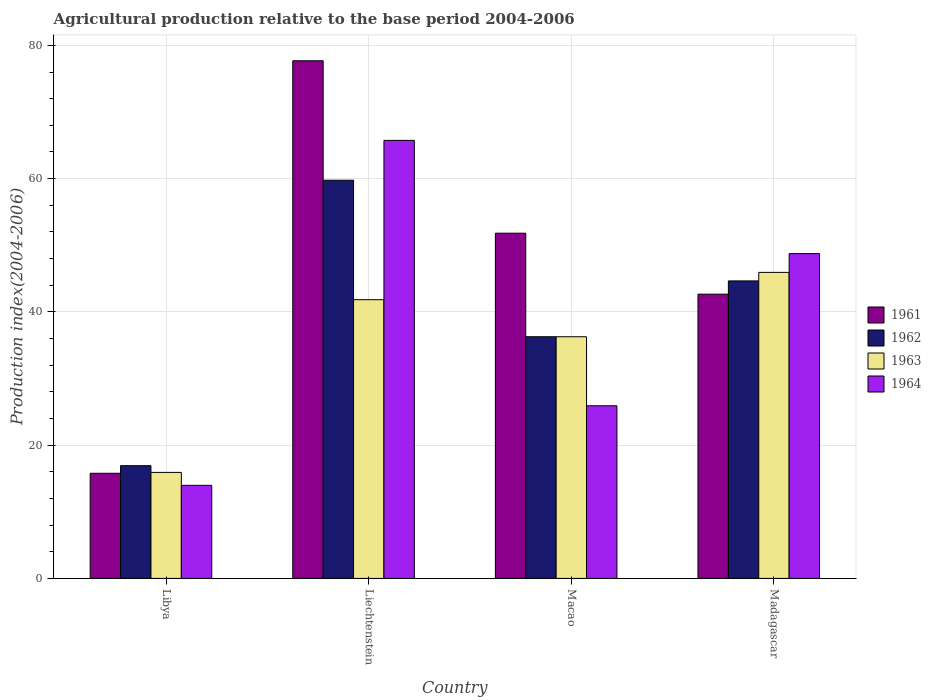How many different coloured bars are there?
Keep it short and to the point. 4. How many groups of bars are there?
Your answer should be very brief. 4. What is the label of the 3rd group of bars from the left?
Your answer should be very brief. Macao. In how many cases, is the number of bars for a given country not equal to the number of legend labels?
Ensure brevity in your answer.  0. What is the agricultural production index in 1962 in Macao?
Give a very brief answer. 36.27. Across all countries, what is the maximum agricultural production index in 1964?
Ensure brevity in your answer.  65.74. Across all countries, what is the minimum agricultural production index in 1961?
Keep it short and to the point. 15.78. In which country was the agricultural production index in 1964 maximum?
Offer a very short reply. Liechtenstein. In which country was the agricultural production index in 1961 minimum?
Provide a succinct answer. Libya. What is the total agricultural production index in 1964 in the graph?
Keep it short and to the point. 154.37. What is the difference between the agricultural production index in 1961 in Libya and that in Madagascar?
Offer a terse response. -26.88. What is the difference between the agricultural production index in 1963 in Liechtenstein and the agricultural production index in 1961 in Madagascar?
Ensure brevity in your answer.  -0.83. What is the average agricultural production index in 1961 per country?
Your answer should be very brief. 46.98. What is the difference between the agricultural production index of/in 1964 and agricultural production index of/in 1961 in Libya?
Make the answer very short. -1.81. In how many countries, is the agricultural production index in 1961 greater than 44?
Your answer should be compact. 2. What is the ratio of the agricultural production index in 1961 in Liechtenstein to that in Macao?
Your response must be concise. 1.5. What is the difference between the highest and the second highest agricultural production index in 1964?
Provide a short and direct response. -16.99. What is the difference between the highest and the lowest agricultural production index in 1963?
Provide a short and direct response. 30.02. What does the 3rd bar from the left in Madagascar represents?
Make the answer very short. 1963. How many countries are there in the graph?
Offer a very short reply. 4. What is the difference between two consecutive major ticks on the Y-axis?
Your answer should be compact. 20. Are the values on the major ticks of Y-axis written in scientific E-notation?
Give a very brief answer. No. Does the graph contain grids?
Your response must be concise. Yes. Where does the legend appear in the graph?
Offer a very short reply. Center right. How many legend labels are there?
Offer a very short reply. 4. How are the legend labels stacked?
Offer a terse response. Vertical. What is the title of the graph?
Offer a very short reply. Agricultural production relative to the base period 2004-2006. Does "2010" appear as one of the legend labels in the graph?
Make the answer very short. No. What is the label or title of the Y-axis?
Keep it short and to the point. Production index(2004-2006). What is the Production index(2004-2006) in 1961 in Libya?
Offer a terse response. 15.78. What is the Production index(2004-2006) in 1962 in Libya?
Keep it short and to the point. 16.92. What is the Production index(2004-2006) of 1963 in Libya?
Give a very brief answer. 15.91. What is the Production index(2004-2006) of 1964 in Libya?
Your answer should be very brief. 13.97. What is the Production index(2004-2006) in 1961 in Liechtenstein?
Provide a short and direct response. 77.69. What is the Production index(2004-2006) of 1962 in Liechtenstein?
Make the answer very short. 59.76. What is the Production index(2004-2006) in 1963 in Liechtenstein?
Provide a succinct answer. 41.83. What is the Production index(2004-2006) of 1964 in Liechtenstein?
Keep it short and to the point. 65.74. What is the Production index(2004-2006) of 1961 in Macao?
Ensure brevity in your answer.  51.81. What is the Production index(2004-2006) in 1962 in Macao?
Offer a very short reply. 36.27. What is the Production index(2004-2006) in 1963 in Macao?
Keep it short and to the point. 36.27. What is the Production index(2004-2006) in 1964 in Macao?
Your answer should be very brief. 25.91. What is the Production index(2004-2006) of 1961 in Madagascar?
Give a very brief answer. 42.66. What is the Production index(2004-2006) in 1962 in Madagascar?
Keep it short and to the point. 44.65. What is the Production index(2004-2006) of 1963 in Madagascar?
Provide a succinct answer. 45.93. What is the Production index(2004-2006) of 1964 in Madagascar?
Offer a very short reply. 48.75. Across all countries, what is the maximum Production index(2004-2006) in 1961?
Your response must be concise. 77.69. Across all countries, what is the maximum Production index(2004-2006) of 1962?
Your answer should be compact. 59.76. Across all countries, what is the maximum Production index(2004-2006) of 1963?
Ensure brevity in your answer.  45.93. Across all countries, what is the maximum Production index(2004-2006) in 1964?
Provide a succinct answer. 65.74. Across all countries, what is the minimum Production index(2004-2006) in 1961?
Make the answer very short. 15.78. Across all countries, what is the minimum Production index(2004-2006) of 1962?
Provide a succinct answer. 16.92. Across all countries, what is the minimum Production index(2004-2006) in 1963?
Your answer should be compact. 15.91. Across all countries, what is the minimum Production index(2004-2006) of 1964?
Offer a terse response. 13.97. What is the total Production index(2004-2006) of 1961 in the graph?
Ensure brevity in your answer.  187.94. What is the total Production index(2004-2006) of 1962 in the graph?
Your answer should be compact. 157.6. What is the total Production index(2004-2006) in 1963 in the graph?
Provide a short and direct response. 139.94. What is the total Production index(2004-2006) in 1964 in the graph?
Your response must be concise. 154.37. What is the difference between the Production index(2004-2006) of 1961 in Libya and that in Liechtenstein?
Your answer should be compact. -61.91. What is the difference between the Production index(2004-2006) of 1962 in Libya and that in Liechtenstein?
Ensure brevity in your answer.  -42.84. What is the difference between the Production index(2004-2006) of 1963 in Libya and that in Liechtenstein?
Ensure brevity in your answer.  -25.92. What is the difference between the Production index(2004-2006) of 1964 in Libya and that in Liechtenstein?
Offer a terse response. -51.77. What is the difference between the Production index(2004-2006) in 1961 in Libya and that in Macao?
Your answer should be compact. -36.03. What is the difference between the Production index(2004-2006) in 1962 in Libya and that in Macao?
Provide a short and direct response. -19.35. What is the difference between the Production index(2004-2006) of 1963 in Libya and that in Macao?
Ensure brevity in your answer.  -20.36. What is the difference between the Production index(2004-2006) in 1964 in Libya and that in Macao?
Offer a terse response. -11.94. What is the difference between the Production index(2004-2006) in 1961 in Libya and that in Madagascar?
Provide a succinct answer. -26.88. What is the difference between the Production index(2004-2006) in 1962 in Libya and that in Madagascar?
Offer a terse response. -27.73. What is the difference between the Production index(2004-2006) in 1963 in Libya and that in Madagascar?
Provide a short and direct response. -30.02. What is the difference between the Production index(2004-2006) in 1964 in Libya and that in Madagascar?
Make the answer very short. -34.78. What is the difference between the Production index(2004-2006) in 1961 in Liechtenstein and that in Macao?
Your response must be concise. 25.88. What is the difference between the Production index(2004-2006) in 1962 in Liechtenstein and that in Macao?
Your response must be concise. 23.49. What is the difference between the Production index(2004-2006) in 1963 in Liechtenstein and that in Macao?
Offer a very short reply. 5.56. What is the difference between the Production index(2004-2006) in 1964 in Liechtenstein and that in Macao?
Give a very brief answer. 39.83. What is the difference between the Production index(2004-2006) of 1961 in Liechtenstein and that in Madagascar?
Provide a short and direct response. 35.03. What is the difference between the Production index(2004-2006) of 1962 in Liechtenstein and that in Madagascar?
Your response must be concise. 15.11. What is the difference between the Production index(2004-2006) in 1963 in Liechtenstein and that in Madagascar?
Keep it short and to the point. -4.1. What is the difference between the Production index(2004-2006) of 1964 in Liechtenstein and that in Madagascar?
Your response must be concise. 16.99. What is the difference between the Production index(2004-2006) in 1961 in Macao and that in Madagascar?
Provide a short and direct response. 9.15. What is the difference between the Production index(2004-2006) in 1962 in Macao and that in Madagascar?
Ensure brevity in your answer.  -8.38. What is the difference between the Production index(2004-2006) of 1963 in Macao and that in Madagascar?
Provide a succinct answer. -9.66. What is the difference between the Production index(2004-2006) in 1964 in Macao and that in Madagascar?
Keep it short and to the point. -22.84. What is the difference between the Production index(2004-2006) in 1961 in Libya and the Production index(2004-2006) in 1962 in Liechtenstein?
Make the answer very short. -43.98. What is the difference between the Production index(2004-2006) in 1961 in Libya and the Production index(2004-2006) in 1963 in Liechtenstein?
Offer a very short reply. -26.05. What is the difference between the Production index(2004-2006) of 1961 in Libya and the Production index(2004-2006) of 1964 in Liechtenstein?
Your answer should be very brief. -49.96. What is the difference between the Production index(2004-2006) of 1962 in Libya and the Production index(2004-2006) of 1963 in Liechtenstein?
Give a very brief answer. -24.91. What is the difference between the Production index(2004-2006) of 1962 in Libya and the Production index(2004-2006) of 1964 in Liechtenstein?
Offer a terse response. -48.82. What is the difference between the Production index(2004-2006) of 1963 in Libya and the Production index(2004-2006) of 1964 in Liechtenstein?
Make the answer very short. -49.83. What is the difference between the Production index(2004-2006) in 1961 in Libya and the Production index(2004-2006) in 1962 in Macao?
Your answer should be very brief. -20.49. What is the difference between the Production index(2004-2006) of 1961 in Libya and the Production index(2004-2006) of 1963 in Macao?
Offer a very short reply. -20.49. What is the difference between the Production index(2004-2006) in 1961 in Libya and the Production index(2004-2006) in 1964 in Macao?
Keep it short and to the point. -10.13. What is the difference between the Production index(2004-2006) in 1962 in Libya and the Production index(2004-2006) in 1963 in Macao?
Your answer should be compact. -19.35. What is the difference between the Production index(2004-2006) in 1962 in Libya and the Production index(2004-2006) in 1964 in Macao?
Keep it short and to the point. -8.99. What is the difference between the Production index(2004-2006) of 1963 in Libya and the Production index(2004-2006) of 1964 in Macao?
Offer a very short reply. -10. What is the difference between the Production index(2004-2006) in 1961 in Libya and the Production index(2004-2006) in 1962 in Madagascar?
Make the answer very short. -28.87. What is the difference between the Production index(2004-2006) of 1961 in Libya and the Production index(2004-2006) of 1963 in Madagascar?
Keep it short and to the point. -30.15. What is the difference between the Production index(2004-2006) of 1961 in Libya and the Production index(2004-2006) of 1964 in Madagascar?
Give a very brief answer. -32.97. What is the difference between the Production index(2004-2006) of 1962 in Libya and the Production index(2004-2006) of 1963 in Madagascar?
Make the answer very short. -29.01. What is the difference between the Production index(2004-2006) of 1962 in Libya and the Production index(2004-2006) of 1964 in Madagascar?
Provide a short and direct response. -31.83. What is the difference between the Production index(2004-2006) of 1963 in Libya and the Production index(2004-2006) of 1964 in Madagascar?
Your response must be concise. -32.84. What is the difference between the Production index(2004-2006) in 1961 in Liechtenstein and the Production index(2004-2006) in 1962 in Macao?
Offer a terse response. 41.42. What is the difference between the Production index(2004-2006) of 1961 in Liechtenstein and the Production index(2004-2006) of 1963 in Macao?
Your response must be concise. 41.42. What is the difference between the Production index(2004-2006) in 1961 in Liechtenstein and the Production index(2004-2006) in 1964 in Macao?
Offer a very short reply. 51.78. What is the difference between the Production index(2004-2006) in 1962 in Liechtenstein and the Production index(2004-2006) in 1963 in Macao?
Ensure brevity in your answer.  23.49. What is the difference between the Production index(2004-2006) of 1962 in Liechtenstein and the Production index(2004-2006) of 1964 in Macao?
Make the answer very short. 33.85. What is the difference between the Production index(2004-2006) in 1963 in Liechtenstein and the Production index(2004-2006) in 1964 in Macao?
Your answer should be compact. 15.92. What is the difference between the Production index(2004-2006) in 1961 in Liechtenstein and the Production index(2004-2006) in 1962 in Madagascar?
Your response must be concise. 33.04. What is the difference between the Production index(2004-2006) in 1961 in Liechtenstein and the Production index(2004-2006) in 1963 in Madagascar?
Provide a short and direct response. 31.76. What is the difference between the Production index(2004-2006) in 1961 in Liechtenstein and the Production index(2004-2006) in 1964 in Madagascar?
Provide a succinct answer. 28.94. What is the difference between the Production index(2004-2006) in 1962 in Liechtenstein and the Production index(2004-2006) in 1963 in Madagascar?
Your answer should be compact. 13.83. What is the difference between the Production index(2004-2006) of 1962 in Liechtenstein and the Production index(2004-2006) of 1964 in Madagascar?
Keep it short and to the point. 11.01. What is the difference between the Production index(2004-2006) of 1963 in Liechtenstein and the Production index(2004-2006) of 1964 in Madagascar?
Keep it short and to the point. -6.92. What is the difference between the Production index(2004-2006) of 1961 in Macao and the Production index(2004-2006) of 1962 in Madagascar?
Keep it short and to the point. 7.16. What is the difference between the Production index(2004-2006) in 1961 in Macao and the Production index(2004-2006) in 1963 in Madagascar?
Ensure brevity in your answer.  5.88. What is the difference between the Production index(2004-2006) in 1961 in Macao and the Production index(2004-2006) in 1964 in Madagascar?
Your answer should be very brief. 3.06. What is the difference between the Production index(2004-2006) in 1962 in Macao and the Production index(2004-2006) in 1963 in Madagascar?
Keep it short and to the point. -9.66. What is the difference between the Production index(2004-2006) in 1962 in Macao and the Production index(2004-2006) in 1964 in Madagascar?
Give a very brief answer. -12.48. What is the difference between the Production index(2004-2006) in 1963 in Macao and the Production index(2004-2006) in 1964 in Madagascar?
Offer a very short reply. -12.48. What is the average Production index(2004-2006) of 1961 per country?
Provide a short and direct response. 46.98. What is the average Production index(2004-2006) in 1962 per country?
Your response must be concise. 39.4. What is the average Production index(2004-2006) of 1963 per country?
Offer a very short reply. 34.98. What is the average Production index(2004-2006) in 1964 per country?
Offer a very short reply. 38.59. What is the difference between the Production index(2004-2006) of 1961 and Production index(2004-2006) of 1962 in Libya?
Your answer should be very brief. -1.14. What is the difference between the Production index(2004-2006) in 1961 and Production index(2004-2006) in 1963 in Libya?
Keep it short and to the point. -0.13. What is the difference between the Production index(2004-2006) in 1961 and Production index(2004-2006) in 1964 in Libya?
Ensure brevity in your answer.  1.81. What is the difference between the Production index(2004-2006) in 1962 and Production index(2004-2006) in 1963 in Libya?
Give a very brief answer. 1.01. What is the difference between the Production index(2004-2006) of 1962 and Production index(2004-2006) of 1964 in Libya?
Provide a short and direct response. 2.95. What is the difference between the Production index(2004-2006) in 1963 and Production index(2004-2006) in 1964 in Libya?
Keep it short and to the point. 1.94. What is the difference between the Production index(2004-2006) of 1961 and Production index(2004-2006) of 1962 in Liechtenstein?
Offer a terse response. 17.93. What is the difference between the Production index(2004-2006) in 1961 and Production index(2004-2006) in 1963 in Liechtenstein?
Give a very brief answer. 35.86. What is the difference between the Production index(2004-2006) in 1961 and Production index(2004-2006) in 1964 in Liechtenstein?
Provide a short and direct response. 11.95. What is the difference between the Production index(2004-2006) in 1962 and Production index(2004-2006) in 1963 in Liechtenstein?
Ensure brevity in your answer.  17.93. What is the difference between the Production index(2004-2006) of 1962 and Production index(2004-2006) of 1964 in Liechtenstein?
Your answer should be compact. -5.98. What is the difference between the Production index(2004-2006) in 1963 and Production index(2004-2006) in 1964 in Liechtenstein?
Make the answer very short. -23.91. What is the difference between the Production index(2004-2006) in 1961 and Production index(2004-2006) in 1962 in Macao?
Offer a terse response. 15.54. What is the difference between the Production index(2004-2006) of 1961 and Production index(2004-2006) of 1963 in Macao?
Your answer should be compact. 15.54. What is the difference between the Production index(2004-2006) of 1961 and Production index(2004-2006) of 1964 in Macao?
Your answer should be compact. 25.9. What is the difference between the Production index(2004-2006) of 1962 and Production index(2004-2006) of 1963 in Macao?
Your response must be concise. 0. What is the difference between the Production index(2004-2006) of 1962 and Production index(2004-2006) of 1964 in Macao?
Provide a succinct answer. 10.36. What is the difference between the Production index(2004-2006) of 1963 and Production index(2004-2006) of 1964 in Macao?
Ensure brevity in your answer.  10.36. What is the difference between the Production index(2004-2006) of 1961 and Production index(2004-2006) of 1962 in Madagascar?
Your response must be concise. -1.99. What is the difference between the Production index(2004-2006) of 1961 and Production index(2004-2006) of 1963 in Madagascar?
Your answer should be compact. -3.27. What is the difference between the Production index(2004-2006) of 1961 and Production index(2004-2006) of 1964 in Madagascar?
Offer a very short reply. -6.09. What is the difference between the Production index(2004-2006) of 1962 and Production index(2004-2006) of 1963 in Madagascar?
Provide a short and direct response. -1.28. What is the difference between the Production index(2004-2006) in 1963 and Production index(2004-2006) in 1964 in Madagascar?
Ensure brevity in your answer.  -2.82. What is the ratio of the Production index(2004-2006) in 1961 in Libya to that in Liechtenstein?
Make the answer very short. 0.2. What is the ratio of the Production index(2004-2006) of 1962 in Libya to that in Liechtenstein?
Your answer should be very brief. 0.28. What is the ratio of the Production index(2004-2006) in 1963 in Libya to that in Liechtenstein?
Keep it short and to the point. 0.38. What is the ratio of the Production index(2004-2006) in 1964 in Libya to that in Liechtenstein?
Your answer should be very brief. 0.21. What is the ratio of the Production index(2004-2006) of 1961 in Libya to that in Macao?
Your response must be concise. 0.3. What is the ratio of the Production index(2004-2006) in 1962 in Libya to that in Macao?
Your answer should be very brief. 0.47. What is the ratio of the Production index(2004-2006) in 1963 in Libya to that in Macao?
Provide a succinct answer. 0.44. What is the ratio of the Production index(2004-2006) of 1964 in Libya to that in Macao?
Provide a succinct answer. 0.54. What is the ratio of the Production index(2004-2006) in 1961 in Libya to that in Madagascar?
Your answer should be compact. 0.37. What is the ratio of the Production index(2004-2006) in 1962 in Libya to that in Madagascar?
Make the answer very short. 0.38. What is the ratio of the Production index(2004-2006) in 1963 in Libya to that in Madagascar?
Offer a very short reply. 0.35. What is the ratio of the Production index(2004-2006) in 1964 in Libya to that in Madagascar?
Keep it short and to the point. 0.29. What is the ratio of the Production index(2004-2006) of 1961 in Liechtenstein to that in Macao?
Offer a terse response. 1.5. What is the ratio of the Production index(2004-2006) of 1962 in Liechtenstein to that in Macao?
Provide a short and direct response. 1.65. What is the ratio of the Production index(2004-2006) in 1963 in Liechtenstein to that in Macao?
Your answer should be compact. 1.15. What is the ratio of the Production index(2004-2006) of 1964 in Liechtenstein to that in Macao?
Offer a terse response. 2.54. What is the ratio of the Production index(2004-2006) of 1961 in Liechtenstein to that in Madagascar?
Offer a terse response. 1.82. What is the ratio of the Production index(2004-2006) of 1962 in Liechtenstein to that in Madagascar?
Offer a very short reply. 1.34. What is the ratio of the Production index(2004-2006) of 1963 in Liechtenstein to that in Madagascar?
Provide a succinct answer. 0.91. What is the ratio of the Production index(2004-2006) of 1964 in Liechtenstein to that in Madagascar?
Your response must be concise. 1.35. What is the ratio of the Production index(2004-2006) of 1961 in Macao to that in Madagascar?
Provide a short and direct response. 1.21. What is the ratio of the Production index(2004-2006) of 1962 in Macao to that in Madagascar?
Make the answer very short. 0.81. What is the ratio of the Production index(2004-2006) of 1963 in Macao to that in Madagascar?
Give a very brief answer. 0.79. What is the ratio of the Production index(2004-2006) in 1964 in Macao to that in Madagascar?
Ensure brevity in your answer.  0.53. What is the difference between the highest and the second highest Production index(2004-2006) of 1961?
Provide a succinct answer. 25.88. What is the difference between the highest and the second highest Production index(2004-2006) in 1962?
Provide a succinct answer. 15.11. What is the difference between the highest and the second highest Production index(2004-2006) of 1964?
Provide a short and direct response. 16.99. What is the difference between the highest and the lowest Production index(2004-2006) of 1961?
Keep it short and to the point. 61.91. What is the difference between the highest and the lowest Production index(2004-2006) in 1962?
Keep it short and to the point. 42.84. What is the difference between the highest and the lowest Production index(2004-2006) in 1963?
Make the answer very short. 30.02. What is the difference between the highest and the lowest Production index(2004-2006) in 1964?
Make the answer very short. 51.77. 